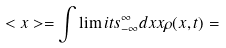<formula> <loc_0><loc_0><loc_500><loc_500>< x > = \int \lim i t s _ { - \infty } ^ { \infty } d x x \rho ( x , t ) =</formula> 